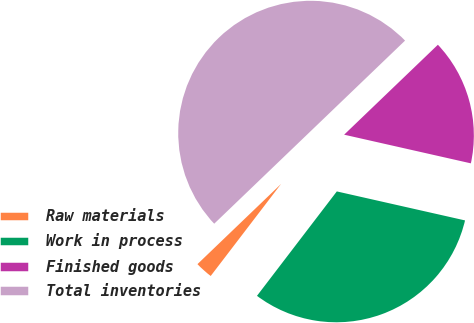Convert chart. <chart><loc_0><loc_0><loc_500><loc_500><pie_chart><fcel>Raw materials<fcel>Work in process<fcel>Finished goods<fcel>Total inventories<nl><fcel>2.44%<fcel>31.85%<fcel>15.71%<fcel>50.0%<nl></chart> 